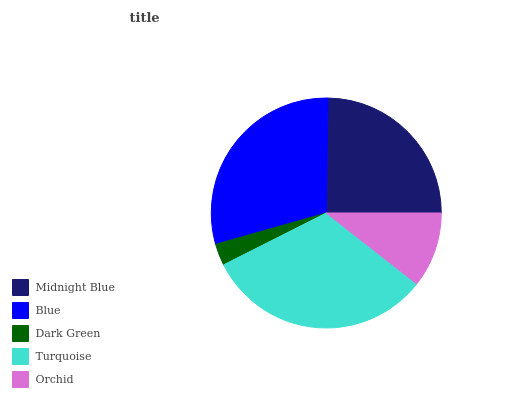Is Dark Green the minimum?
Answer yes or no. Yes. Is Turquoise the maximum?
Answer yes or no. Yes. Is Blue the minimum?
Answer yes or no. No. Is Blue the maximum?
Answer yes or no. No. Is Blue greater than Midnight Blue?
Answer yes or no. Yes. Is Midnight Blue less than Blue?
Answer yes or no. Yes. Is Midnight Blue greater than Blue?
Answer yes or no. No. Is Blue less than Midnight Blue?
Answer yes or no. No. Is Midnight Blue the high median?
Answer yes or no. Yes. Is Midnight Blue the low median?
Answer yes or no. Yes. Is Orchid the high median?
Answer yes or no. No. Is Blue the low median?
Answer yes or no. No. 